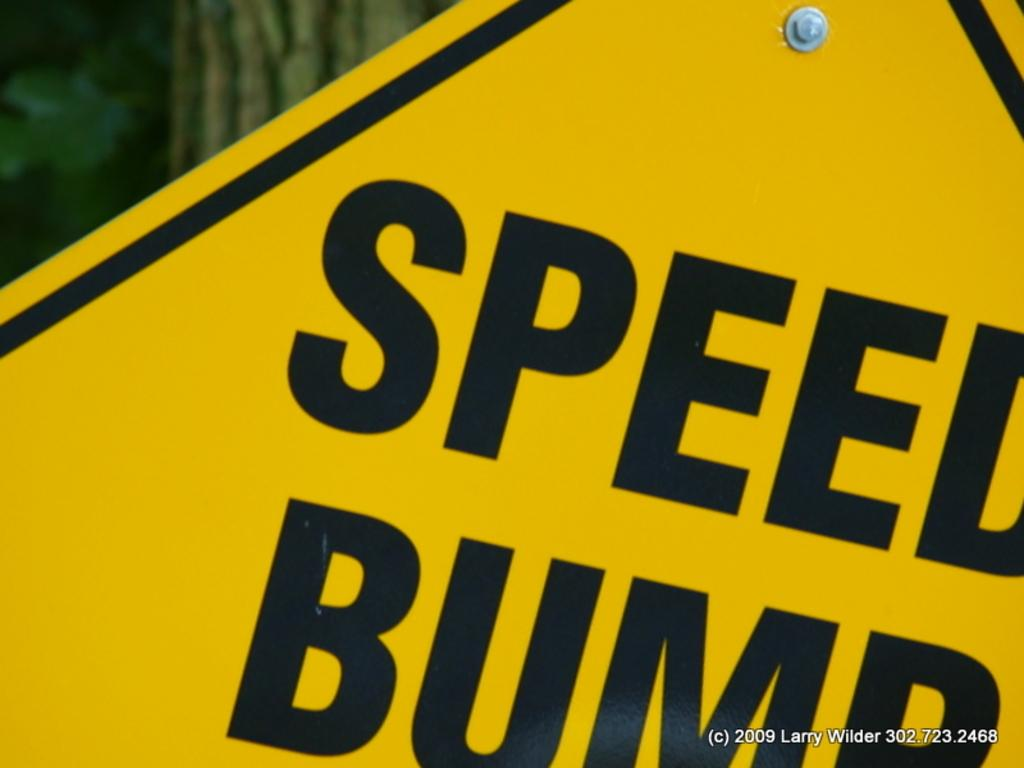<image>
Offer a succinct explanation of the picture presented. A close up of a sign reading Speed Bump. 